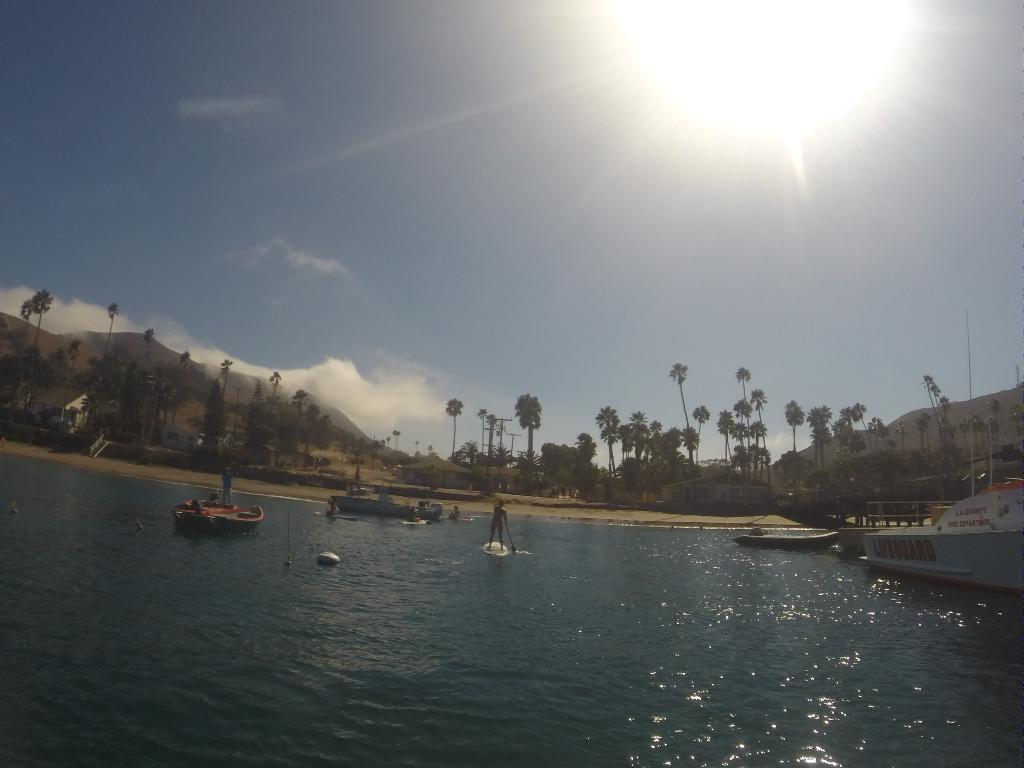What body of water is present in the image? There is a river in the image. What is in the river? There are boats in the river. What can be seen in the background of the image? There are trees, houses, mountains, and the sky visible in the background of the image. How many sisters are sitting on the stove in the image? There are no stoves or sisters present in the image. 